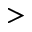Convert formula to latex. <formula><loc_0><loc_0><loc_500><loc_500>></formula> 